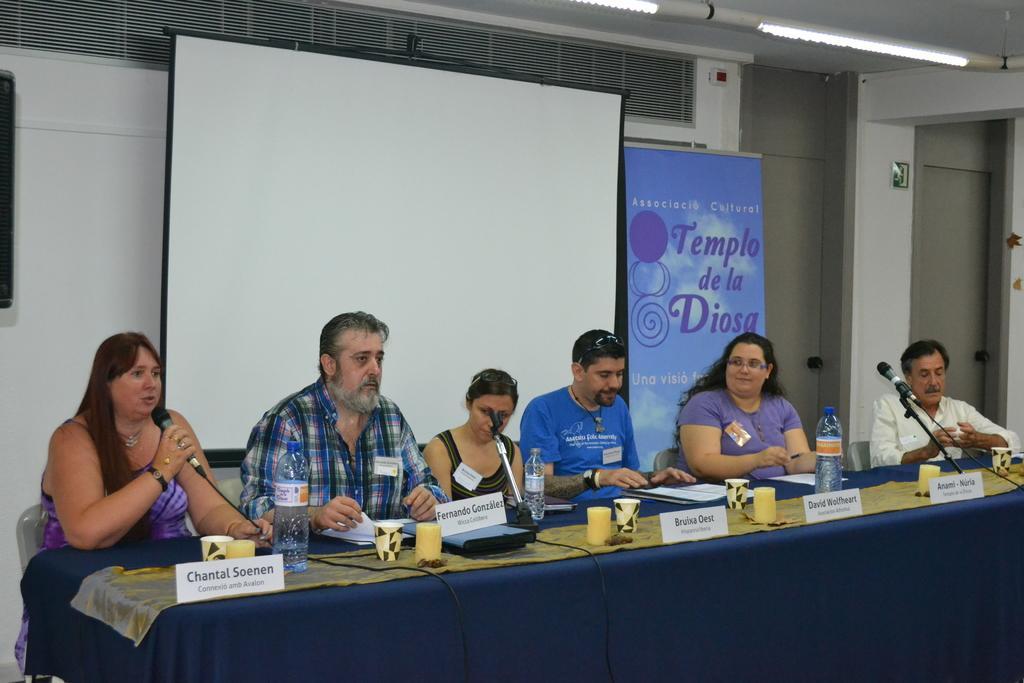Please provide a concise description of this image. In this image In the middle there is a table on that there is a bottle, cups and papers, In front of that there are three people on them On the left there is a woman her hair is short she is speaking. In the back ground there is a white screen ,wall, light, poster and door. 